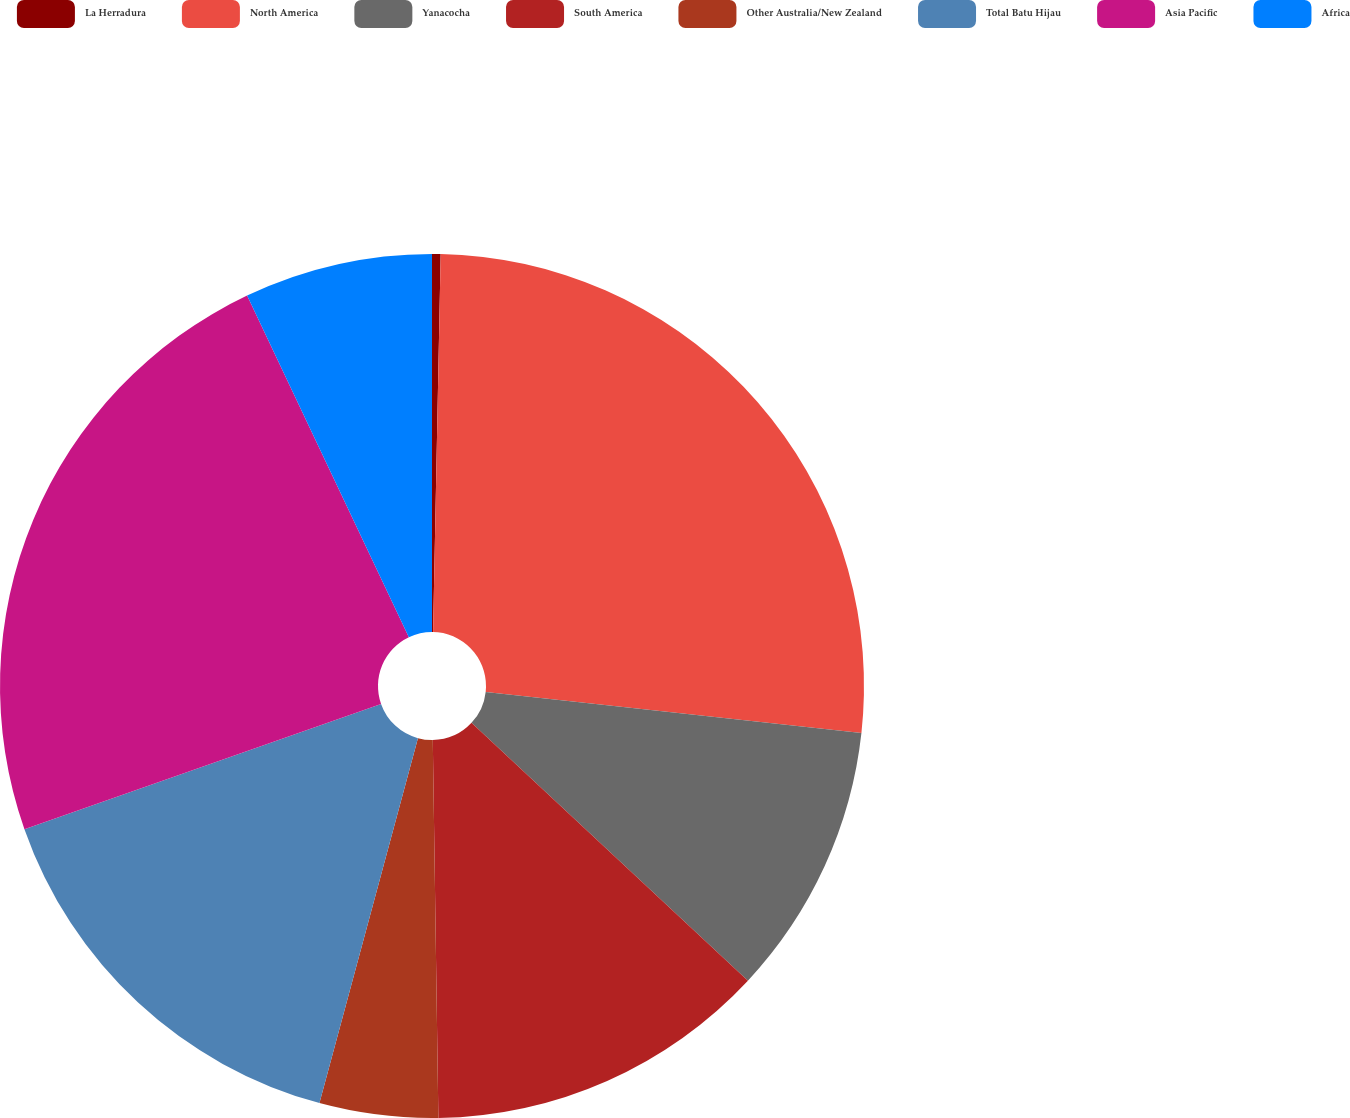Convert chart. <chart><loc_0><loc_0><loc_500><loc_500><pie_chart><fcel>La Herradura<fcel>North America<fcel>Yanacocha<fcel>South America<fcel>Other Australia/New Zealand<fcel>Total Batu Hijau<fcel>Asia Pacific<fcel>Africa<nl><fcel>0.32%<fcel>26.42%<fcel>10.21%<fcel>12.82%<fcel>4.43%<fcel>15.43%<fcel>23.34%<fcel>7.04%<nl></chart> 